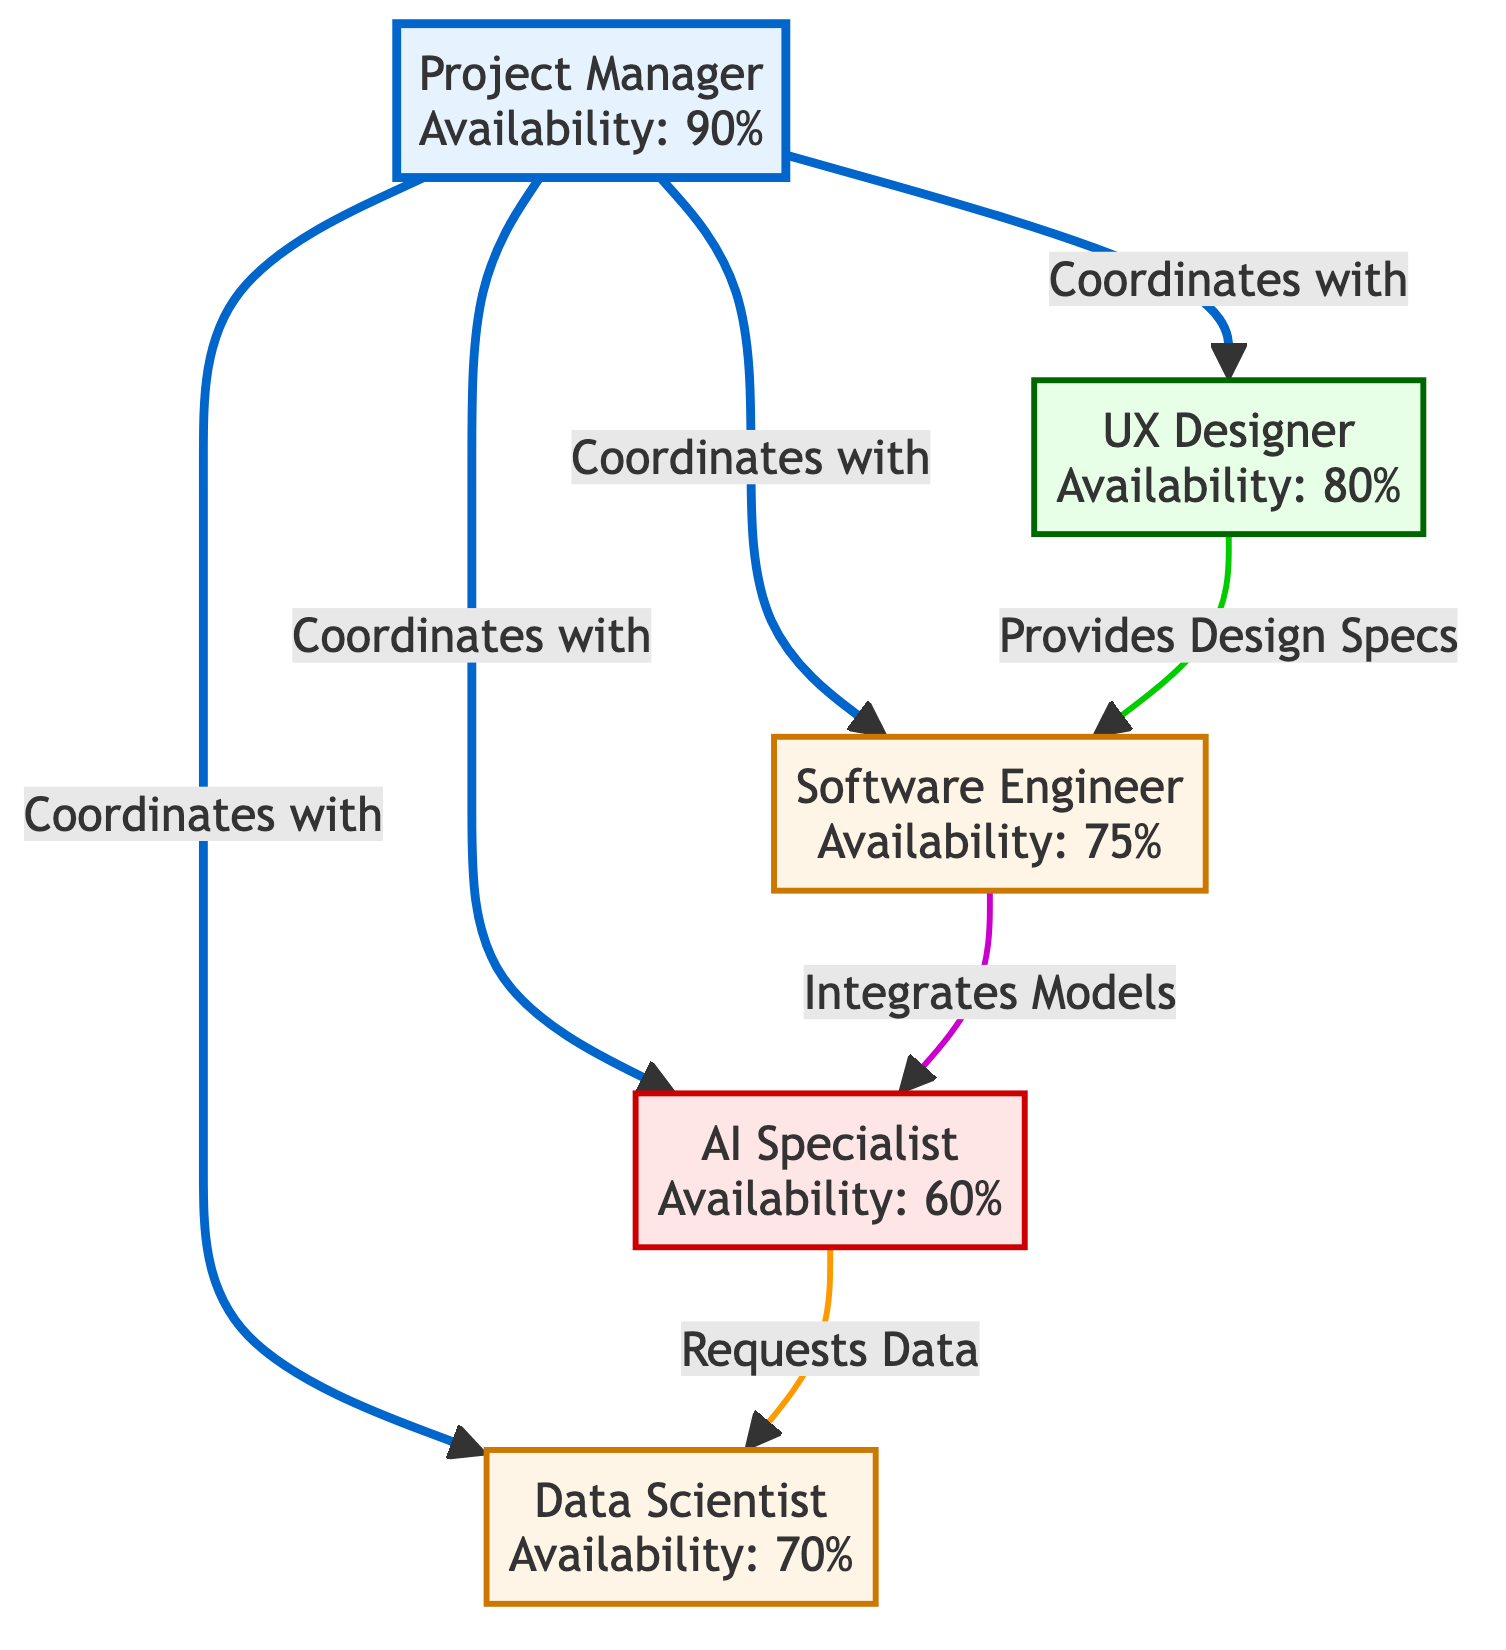What is the availability of the Project Manager? The diagram indicates that the Project Manager's availability is 90%, as detailed in the node description.
Answer: 90% How many nodes are there in total? By counting the unique roles described in the diagram, there are five nodes: Project Manager, UX Designer, Software Engineer, AI Specialist, and Data Scientist.
Answer: 5 Who does the UX Designer provide design specs to? According to the links in the diagram, the UX Designer provides design specs to the Software Engineer.
Answer: Software Engineer What is the role of the AI Specialist? The role of the AI Specialist is described in the node, identifying them as the one who develops AI models.
Answer: Develops AI models Which role has the lowest availability? By comparing the availability percentages listed for each role, the AI Specialist has the lowest availability at 60%.
Answer: AI Specialist How many connections does the Project Manager have? The Project Manager is connected to four other nodes in the diagram, indicating they coordinate with UX Designer, Software Engineer, AI Specialist, and Data Scientist.
Answer: 4 What skills are associated with the Data Scientist? The skills listed for the Data Scientist are Data Cleaning, Statistical Analysis, and SQL, which are provided in the node's description.
Answer: Data Cleaning, Statistical Analysis, SQL Who requests data from the Data Scientist? The diagram shows that the AI Specialist requests data from the Data Scientist, which is mentioned in the connections.
Answer: AI Specialist What is the relationship between the Software Engineer and the AI Specialist? The relationship is defined in the diagram as the Software Engineer integrates models developed by the AI Specialist.
Answer: Integrates Models 